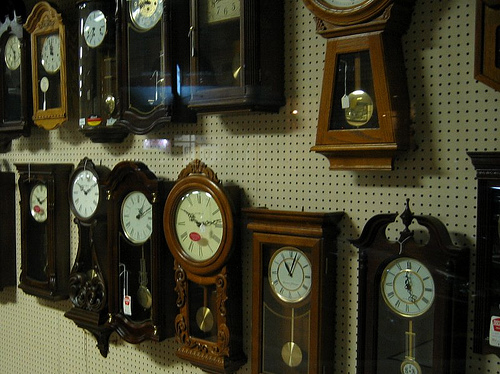<image>What kind of leaves decorate the top of the center clock? I don't know what kind of leaves decorate the top of the center clock. It could be none, filigree, maple, or oak. What kind of leaves decorate the top of the center clock? I don't know what kind of leaves decorate the top of the center clock. It can be seen 'filigree', 'maple' or 'oak'. 